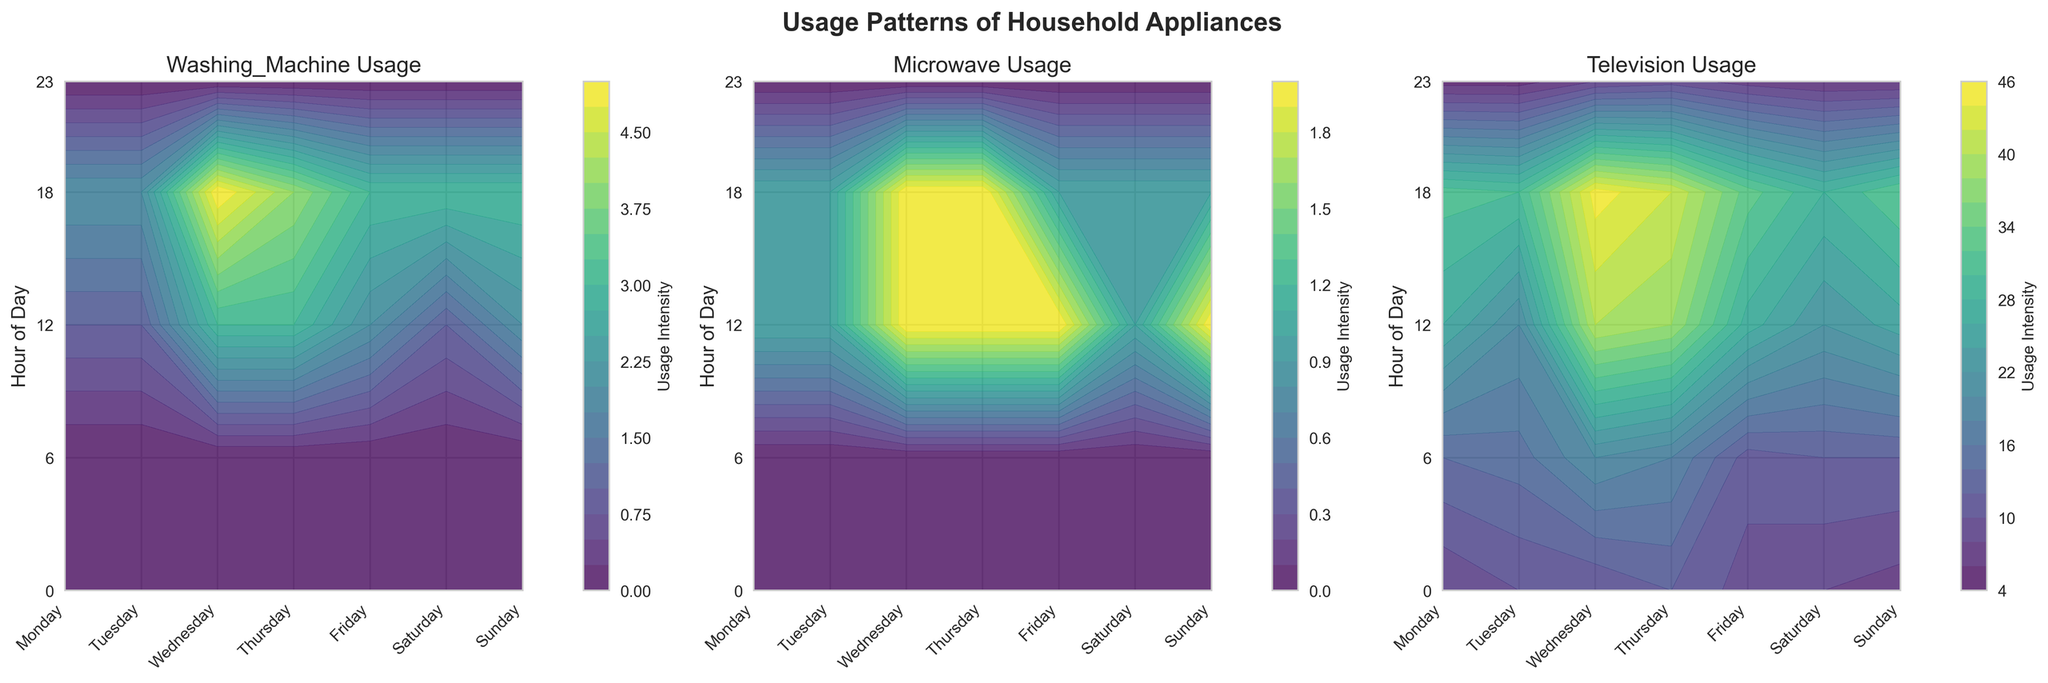Which day and hour have the highest usage for the Washing Machine? Identify the contour plot for the Washing Machine and look for the highest contour value across different days and hours. This peak will indicate the highest usage.
Answer: Saturday at 18:00 Which hour generally shows the least activity for all appliances? For each contour plot, scan the color gradient at different hours. Notice the colors representing the lowest intensities and identify the common hour.
Answer: 0:00 On which day does the Microwave usage peak the most, and at what hour? Focus on the contour plot for Microwave usage. Look for the highest contour value and match it with the corresponding day and hour.
Answer: Saturday at 12:00 Comparing Monday and Wednesday, which day has higher Television usage during peak hours? Compare the contour colors for Television usage on Monday and Wednesday, specifically focusing on the peak hours (18:00). Determine which day has a higher usage based on the intensity of the color.
Answer: Wednesday How does the Washing Machine usage trend differ from the Refrigerator's usage? Observe the contour plots for both Washing Machine and Refrigerator. Note the Washing Machine has varying peaks throughout the week while the Refrigerator maintains a constant usage of 80.
Answer: Varying peaks vs constant usage Which appliance shows the most significant variation in usage across different days of the week? Examine all the contour plots and look for the appliance with the most noticeable changes in contour levels across days.
Answer: Washing Machine At what hour is the Television most used on Sunday, and how can you tell? Refer to the Television contour plot and focus on Sunday. Identify the hour with the highest contour value, which indicates the highest usage.
Answer: 18:00 How does the usage of the Microwave change from Monday to Tuesday at 12:00? Check the contour levels for Microwave usage at 12:00 on Monday and compare it with the 12:00 contour on Tuesday. Note the increase or decrease.
Answer: Increases Which day of the weekend has the lowest Washing Machine usage, and at what hour? Inspect the Washing Machine contour plot for both Saturday and Sunday, looking for the lowest contour levels to determine the day and hour.
Answer: Saturday at 0:00 What is the general trend of appliance usage intensity throughout the day? Analyze the common pattern of usage intensity in all contour plots. Typically, note how usage trends change from midnight to night.
Answer: Increases toward the evening 